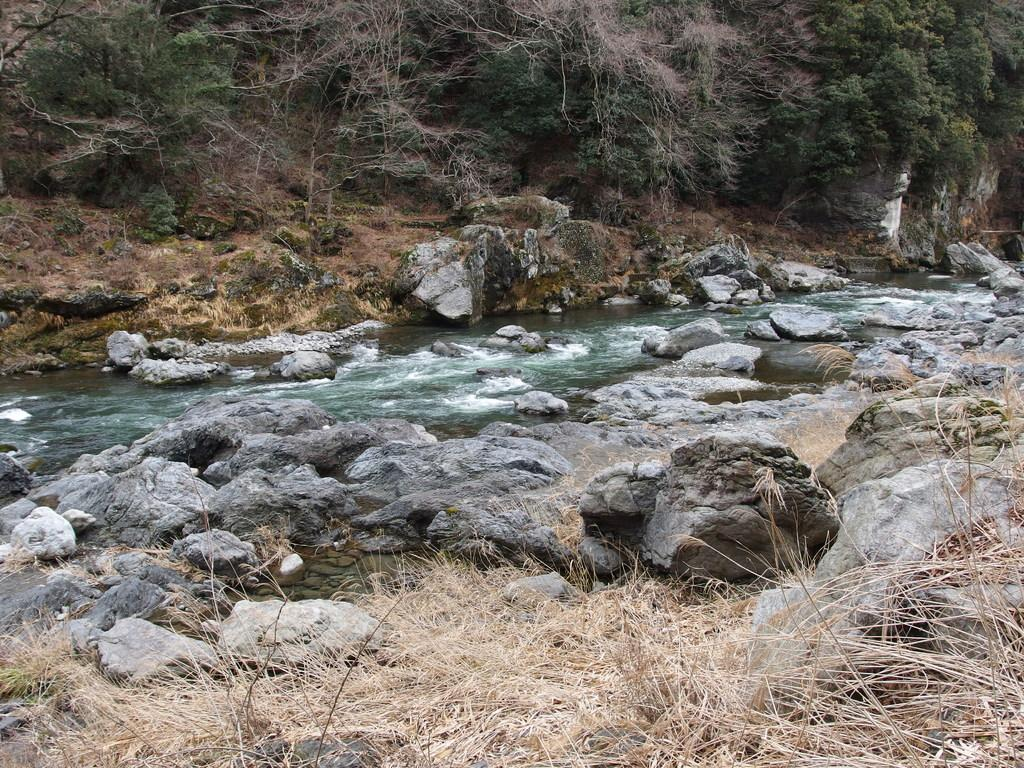What is the main element at the center of the image? There is water at the center of the image. What type of vegetation can be seen at the bottom of the image? There is grass on the surface at the bottom of the image. What other objects are present in the image? There are rocks in the image. What can be seen in the background of the image? There are trees in the background of the image. What type of skirt is being worn by the heart in the image? There is no skirt or heart present in the image; it features water, grass, rocks, and trees. 